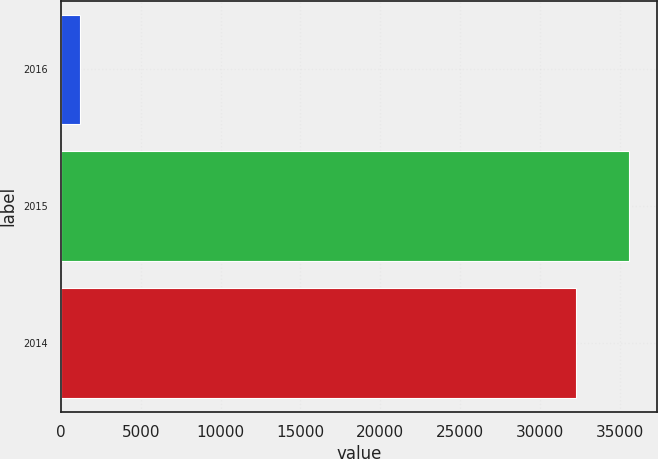Convert chart to OTSL. <chart><loc_0><loc_0><loc_500><loc_500><bar_chart><fcel>2016<fcel>2015<fcel>2014<nl><fcel>1211<fcel>35548.5<fcel>32247<nl></chart> 